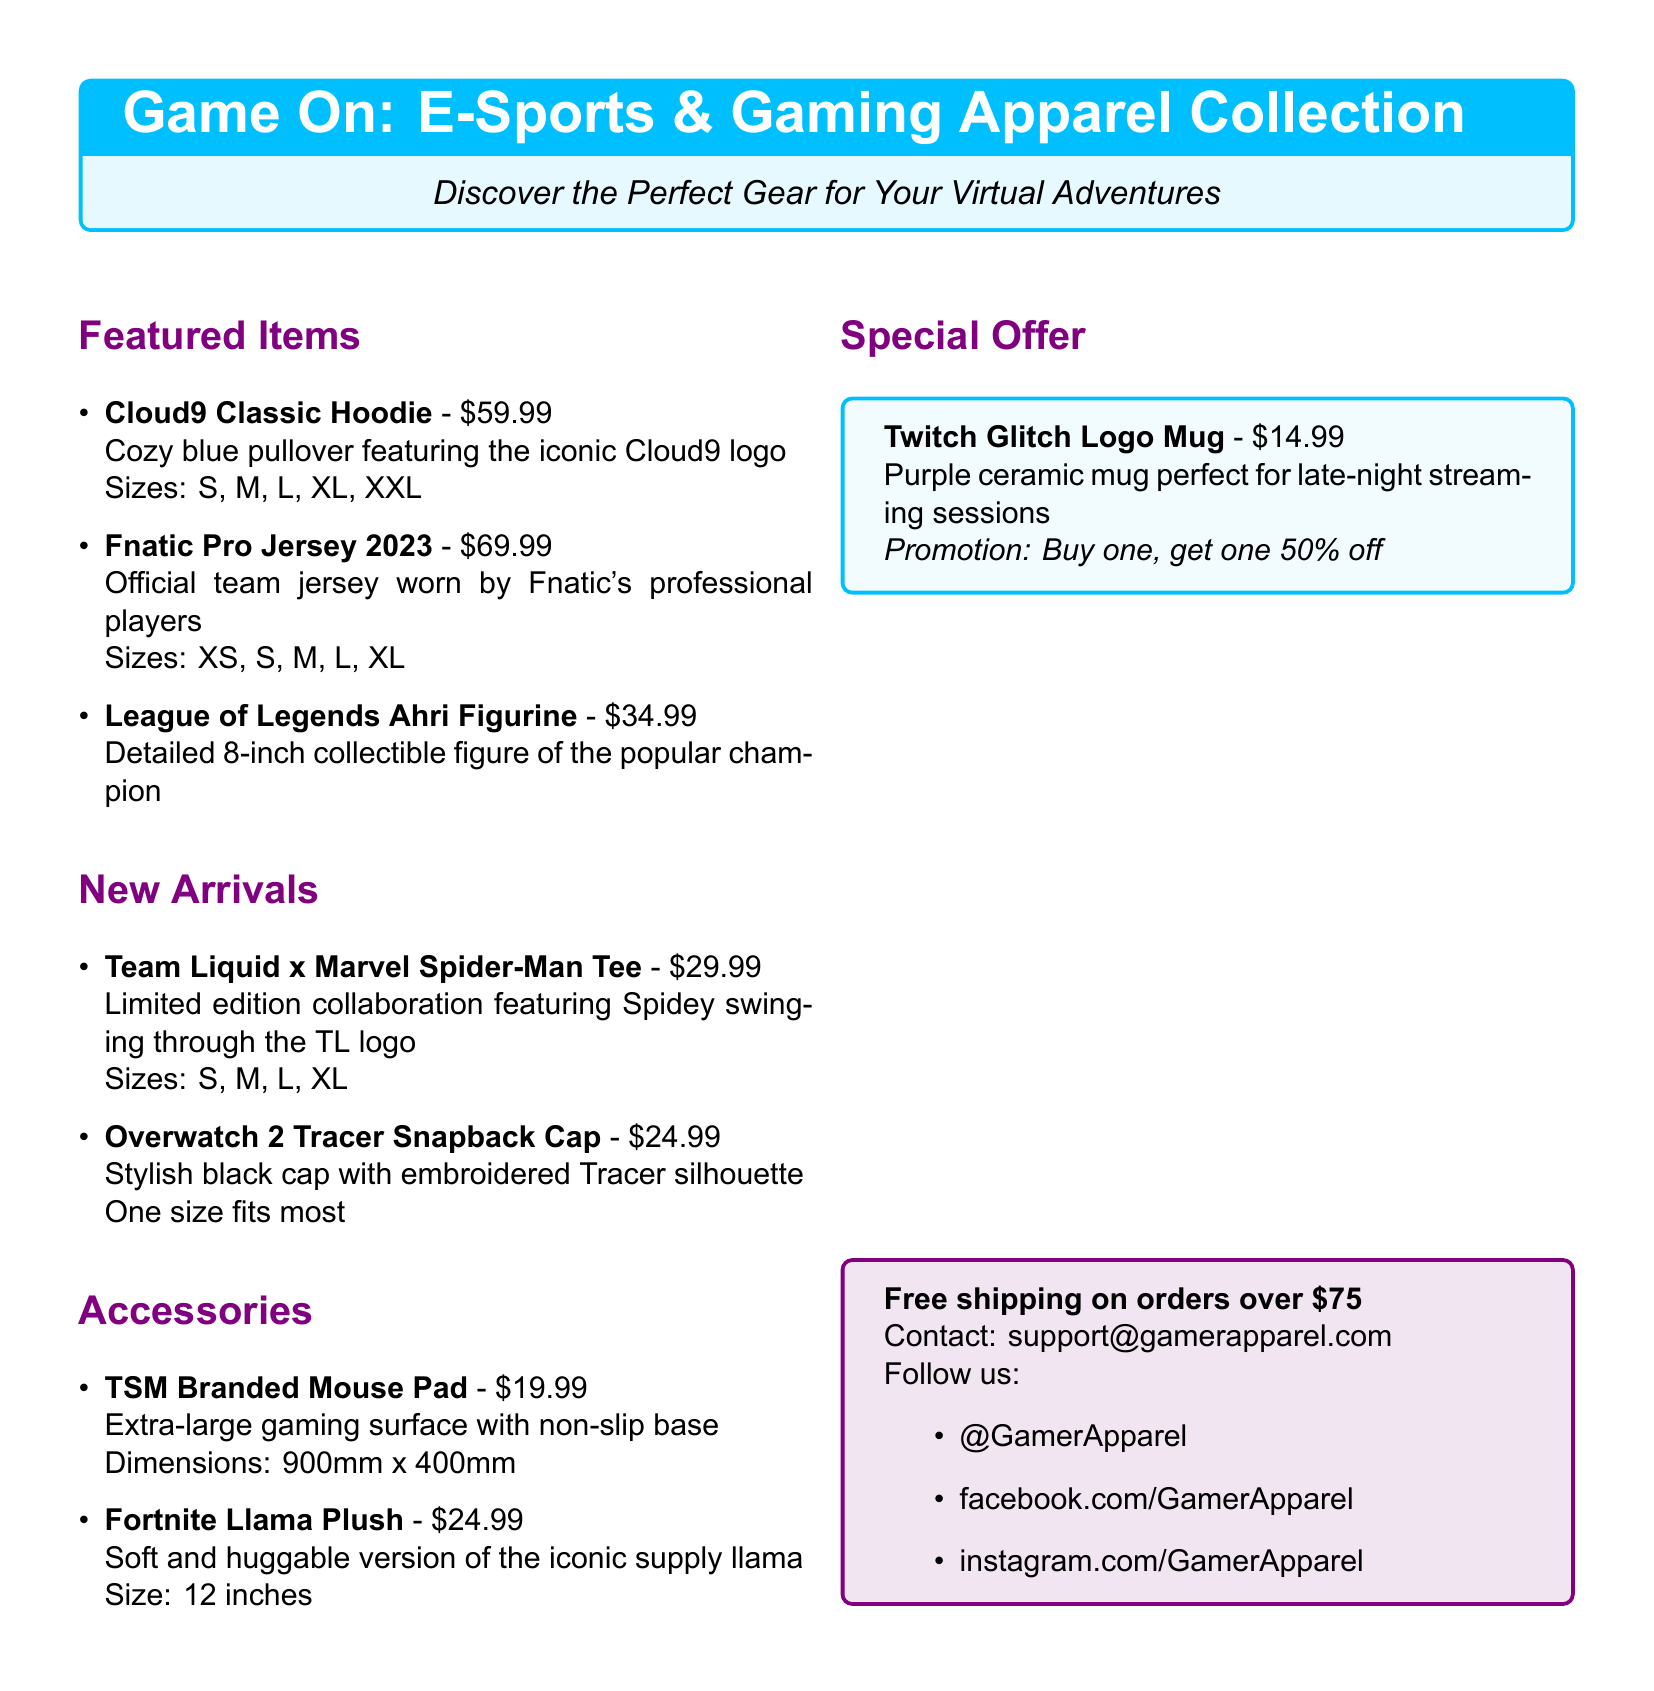what is the price of the Cloud9 Classic Hoodie? The price of the Cloud9 Classic Hoodie is listed in the featured items section of the document.
Answer: \$59.99 how many sizes does the Fnatic Pro Jersey come in? The Fnatic Pro Jersey is available in multiple sizes, specifically noted in the document.
Answer: 5 what item features Spider-Man? The document lists a specific item that features Spider-Man in its title and description.
Answer: Team Liquid x Marvel Spider-Man Tee what is the size of the TSM Branded Mouse Pad? The size of the TSM Branded Mouse Pad is provided in the document under the accessories section.
Answer: 900mm x 400mm what is the promotion for the Twitch Glitch Logo Mug? The document contains a specific promotion for the Twitch Glitch Logo Mug within the special offer section.
Answer: Buy one, get one 50% off which item is a plush toy? The document mentions a specific item classified as a plush toy under the accessories section.
Answer: Fortnite Llama Plush how much does the Overwatch 2 Tracer Snapback Cap cost? The cost of the Overwatch 2 Tracer Snapback Cap is clearly listed in the new arrivals section.
Answer: \$24.99 what color is the Cloud9 Classic Hoodie? The description of the Cloud9 Classic Hoodie specifies its color.
Answer: blue 